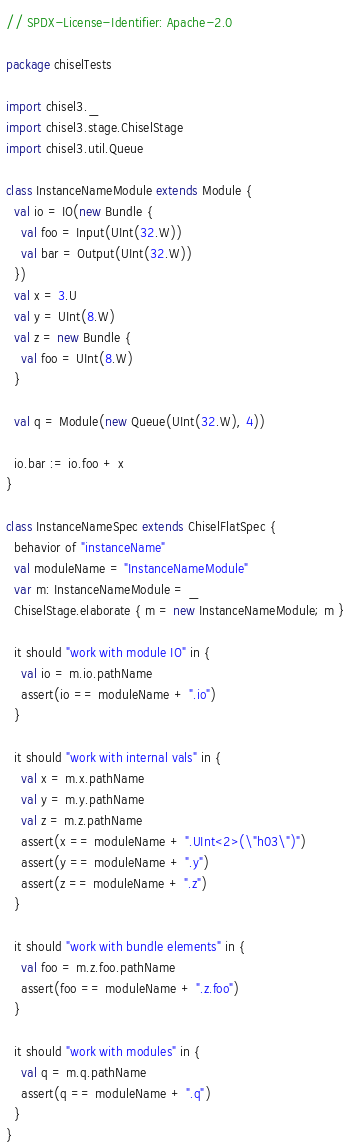<code> <loc_0><loc_0><loc_500><loc_500><_Scala_>// SPDX-License-Identifier: Apache-2.0

package chiselTests

import chisel3._
import chisel3.stage.ChiselStage
import chisel3.util.Queue

class InstanceNameModule extends Module {
  val io = IO(new Bundle {
    val foo = Input(UInt(32.W))
    val bar = Output(UInt(32.W))
  })
  val x = 3.U
  val y = UInt(8.W)
  val z = new Bundle {
    val foo = UInt(8.W)
  }

  val q = Module(new Queue(UInt(32.W), 4))

  io.bar := io.foo + x
}

class InstanceNameSpec extends ChiselFlatSpec {
  behavior of "instanceName"
  val moduleName = "InstanceNameModule"
  var m: InstanceNameModule = _
  ChiselStage.elaborate { m = new InstanceNameModule; m }

  it should "work with module IO" in {
    val io = m.io.pathName
    assert(io == moduleName + ".io")
  }

  it should "work with internal vals" in {
    val x = m.x.pathName
    val y = m.y.pathName
    val z = m.z.pathName
    assert(x == moduleName + ".UInt<2>(\"h03\")")
    assert(y == moduleName + ".y")
    assert(z == moduleName + ".z")
  }

  it should "work with bundle elements" in {
    val foo = m.z.foo.pathName
    assert(foo == moduleName + ".z.foo")
  }

  it should "work with modules" in {
    val q = m.q.pathName
    assert(q == moduleName + ".q")
  }
}
</code> 